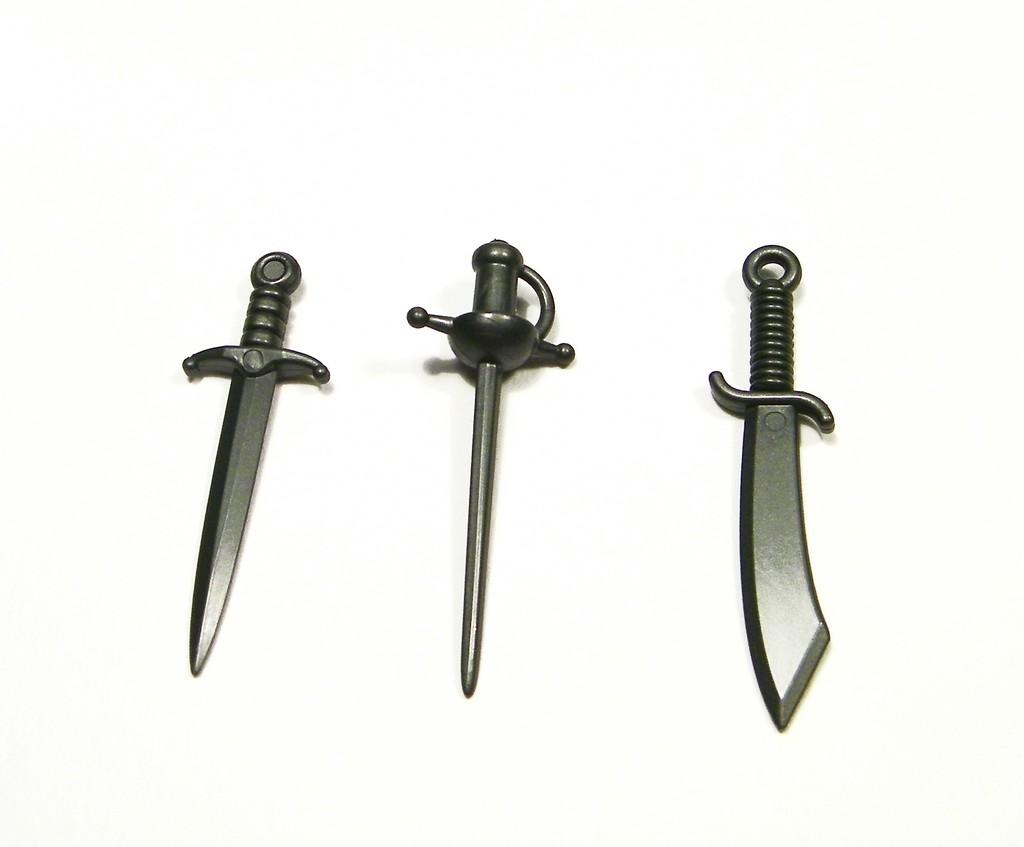How many words are present in the image? There are three words in the image. What colors are used for the words in the image? The words are black and gray in color. What type of coast can be seen in the image? There is no coast present in the image; it only contains three words in black and gray. How does the skate interact with the words in the image? There is no skate present in the image; it only contains three words in black and gray. 